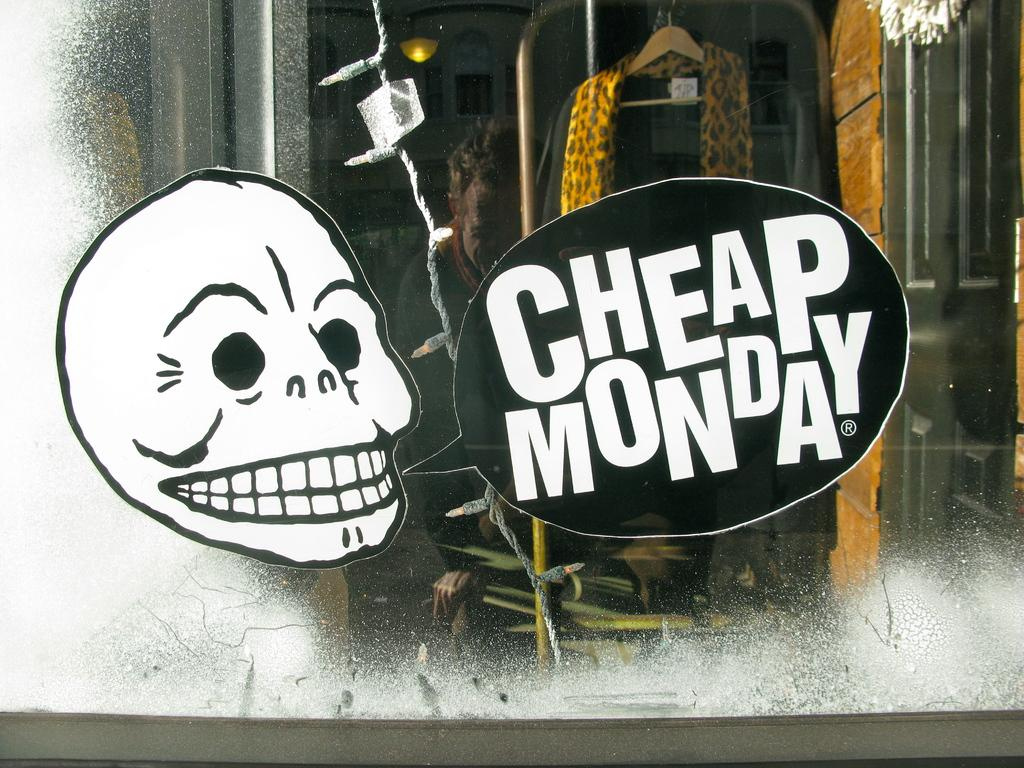What is present on the glass in the foreground of the image? There are two posters on the glass in the foreground. What can be seen in the image besides the posters? There are lights visible in the image. What is located in the background of the image? There is a dress on a hanger in the background. What type of celery is being used as a decoration in the image? There is no celery present in the image. How many balloons are tied to the dress in the background? There are no balloons present in the image. 